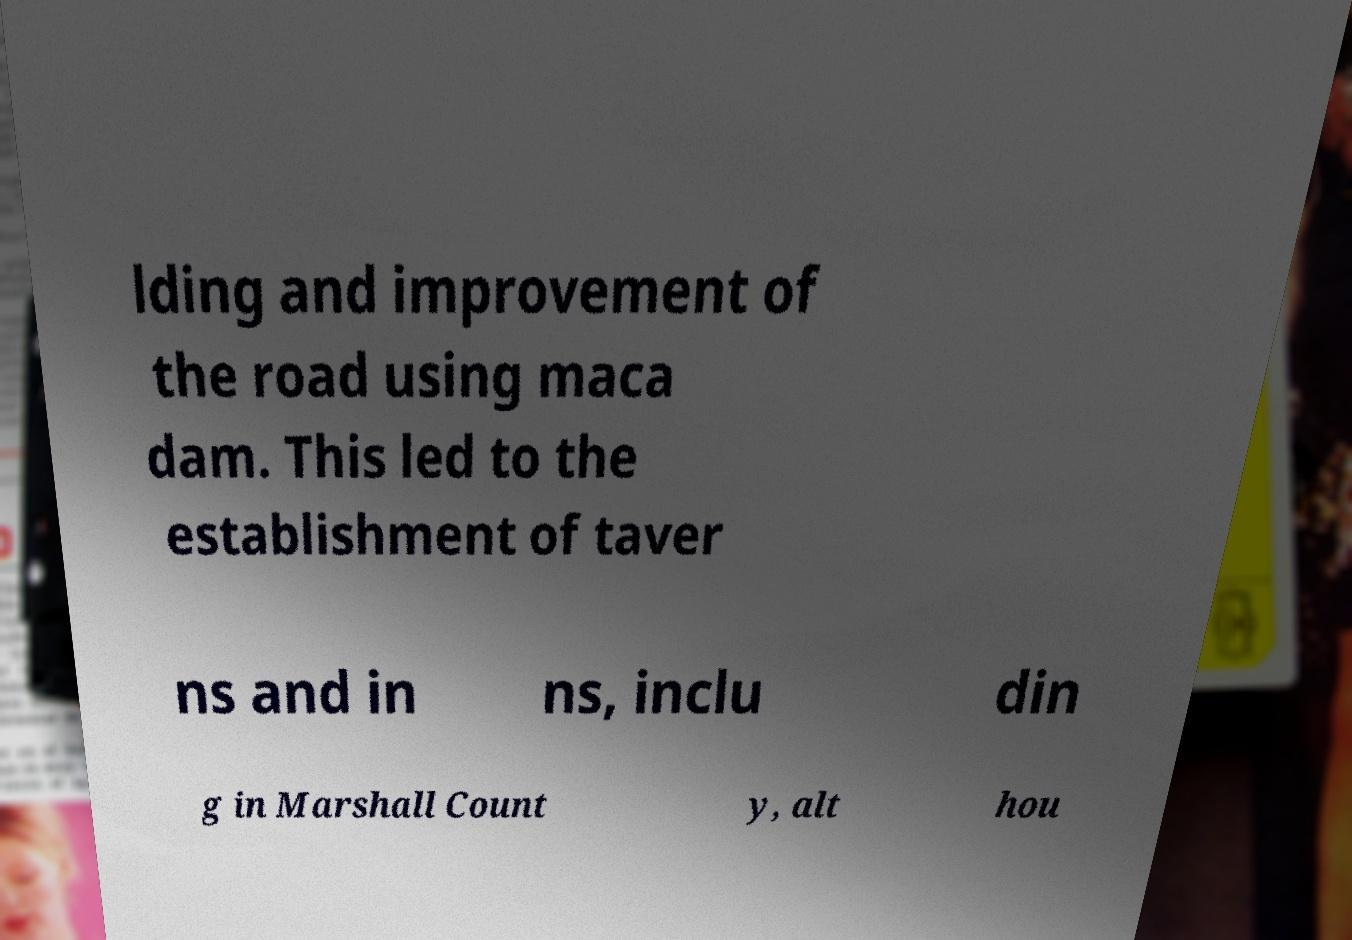Can you accurately transcribe the text from the provided image for me? lding and improvement of the road using maca dam. This led to the establishment of taver ns and in ns, inclu din g in Marshall Count y, alt hou 